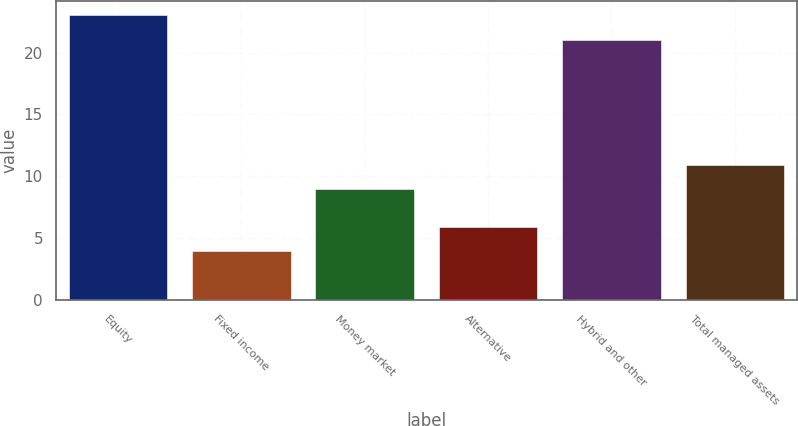Convert chart to OTSL. <chart><loc_0><loc_0><loc_500><loc_500><bar_chart><fcel>Equity<fcel>Fixed income<fcel>Money market<fcel>Alternative<fcel>Hybrid and other<fcel>Total managed assets<nl><fcel>23<fcel>4<fcel>9<fcel>5.9<fcel>21<fcel>10.9<nl></chart> 